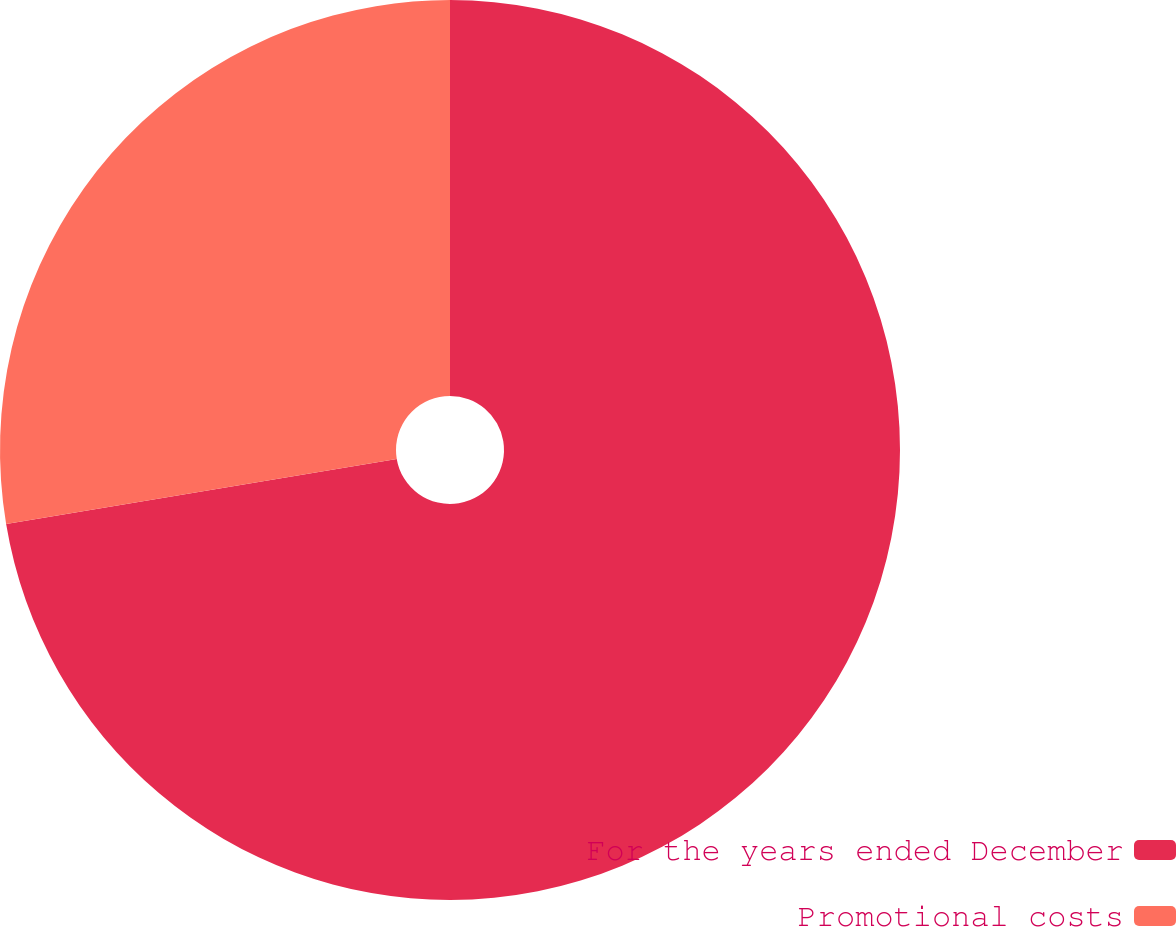Convert chart. <chart><loc_0><loc_0><loc_500><loc_500><pie_chart><fcel>For the years ended December<fcel>Promotional costs<nl><fcel>72.37%<fcel>27.63%<nl></chart> 